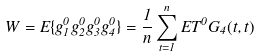<formula> <loc_0><loc_0><loc_500><loc_500>W = { E } \{ g _ { 1 } ^ { 0 } g _ { 2 } ^ { 0 } g _ { 3 } ^ { 0 } g _ { 4 } ^ { 0 } \} = \frac { 1 } { n } \sum _ { t = 1 } ^ { n } { E } T ^ { 0 } G _ { 4 } ( t , t )</formula> 